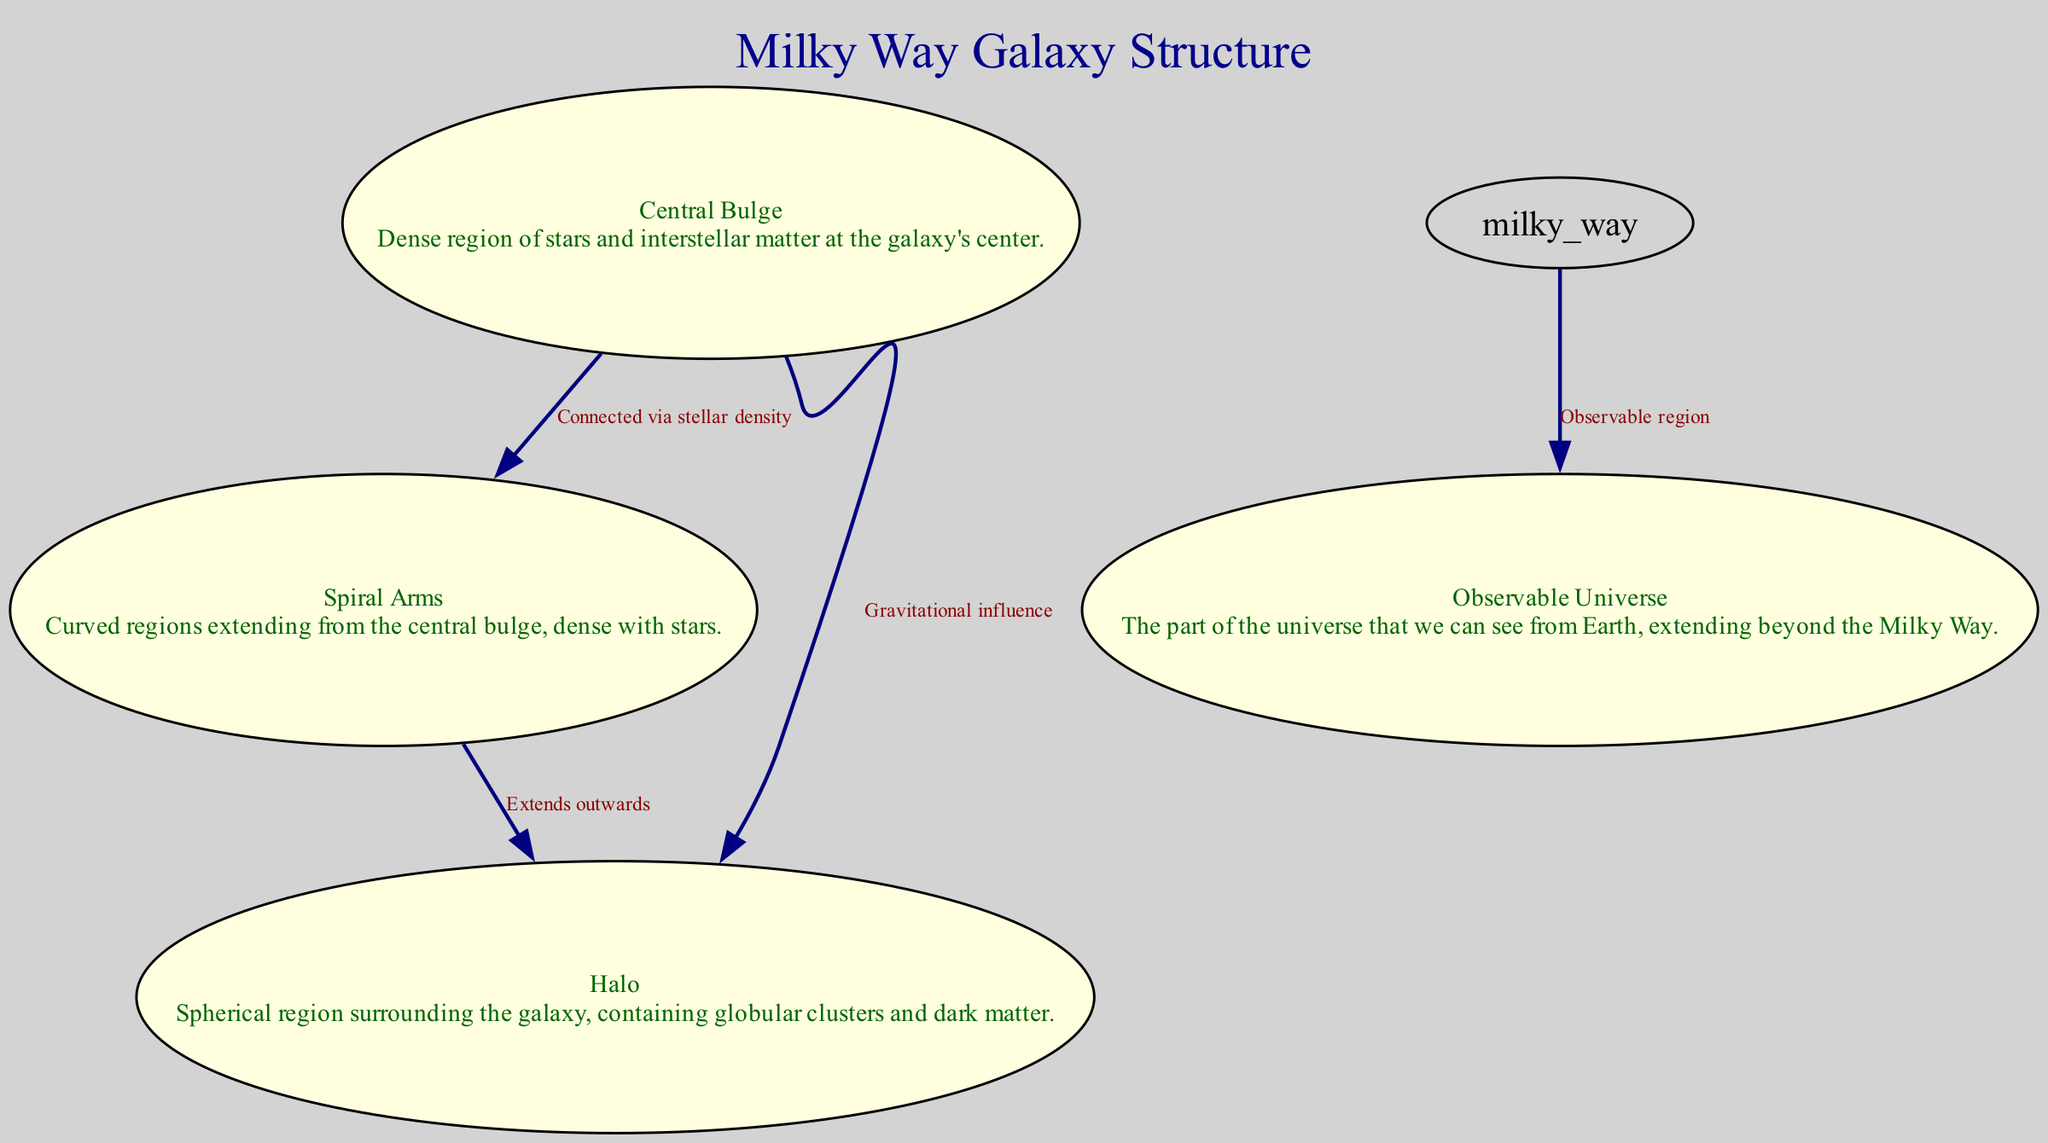What is the label of the node representing the dense region of stars at the galaxy's center? The diagram includes a node labeled "Central Bulge," which describes it as a dense region of stars and interstellar matter at the galaxy's center.
Answer: Central Bulge How many nodes are displayed in the diagram? The diagram lists four distinct nodes: Central Bulge, Spiral Arms, Halo, and Observable Universe. Therefore, the total number of nodes is four.
Answer: 4 What is the connection between the Central Bulge and the Halo? The diagram shows an edge labeled "Gravitational influence" connecting the Central Bulge to the Halo, indicating a relationship based on gravitational effects.
Answer: Gravitational influence Which node is connected to the Spiral Arms through stellar density? The diagram specifies that the Central Bulge is connected to the Spiral Arms via an edge labeled "Connected via stellar density," suggesting a direct relationship of star density between these components.
Answer: Central Bulge What does the Halo contain according to the node description? The description of the Halo node indicates that it contains globular clusters and dark matter, outlining its composition.
Answer: Globular clusters and dark matter What connection extends outwards from the Spiral Arms? The edge labeled "Extends outwards" indicates that the Halo extends outwards from the Spiral Arms, suggesting a spatial relationship between these components.
Answer: Extends outwards How does the Milky Way correlate with the Observable Universe? The diagram depicts an edge labeled "Observable region," indicating a relationship that signifies the Milky Way's visibility in relation to the broader Observable Universe.
Answer: Observable region What is the shape of the Halo based on its description? The node description for the Halo indicates it is described as a "Spherical region," which implies its three-dimensional shape around the galaxy.
Answer: Spherical region 